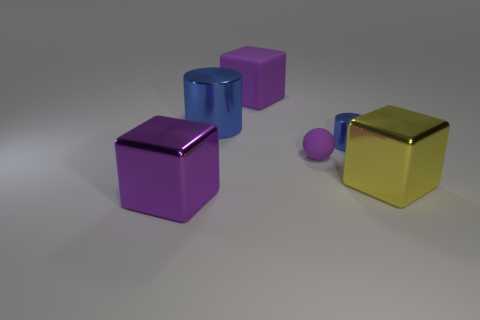Subtract all purple blocks. How many were subtracted if there are1purple blocks left? 1 Subtract all large yellow cubes. How many cubes are left? 2 Subtract all purple cubes. How many cubes are left? 1 Subtract all cylinders. How many objects are left? 4 Add 4 purple shiny things. How many objects exist? 10 Subtract 3 cubes. How many cubes are left? 0 Subtract all small gray balls. Subtract all tiny blue things. How many objects are left? 5 Add 1 big metallic cylinders. How many big metallic cylinders are left? 2 Add 5 tiny purple spheres. How many tiny purple spheres exist? 6 Subtract 0 red cubes. How many objects are left? 6 